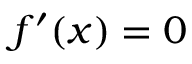<formula> <loc_0><loc_0><loc_500><loc_500>f ^ { \prime } ( x ) = 0</formula> 